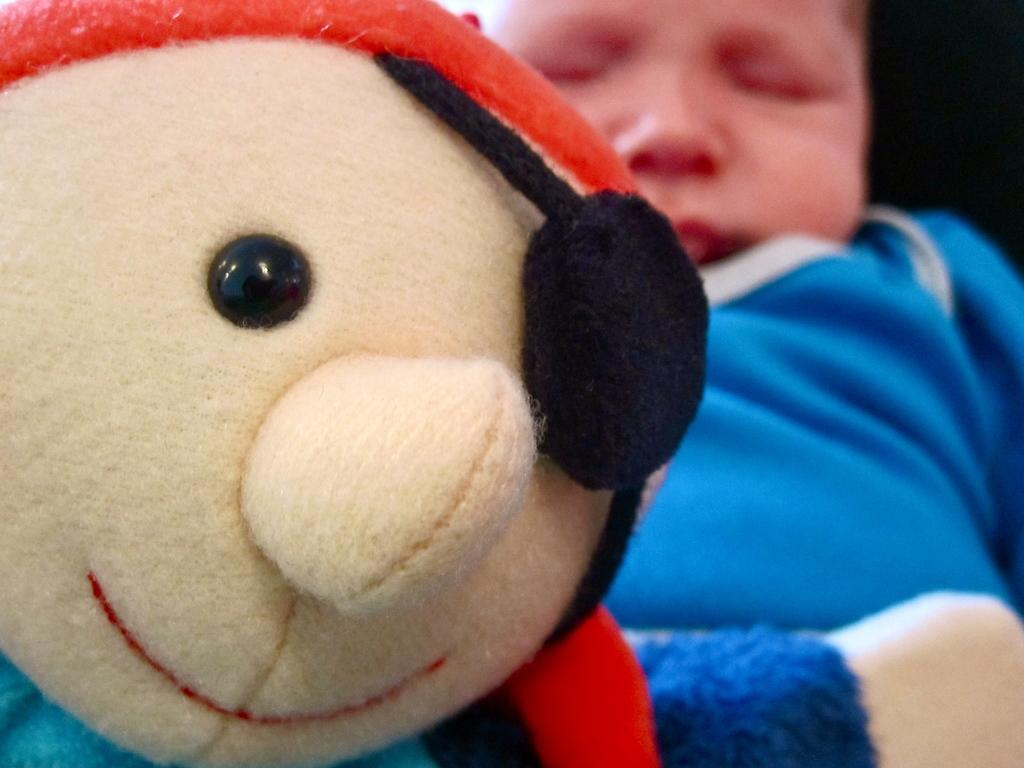What is located on the left side of the image? There is a doll on the left side of the image. What can be seen on the right side of the image? There is a baby sleeping on the right side of the image. What color is the baby's dress? The baby is wearing a blue dress. Is there any smoke visible in the image? No, there is no smoke present in the image. 